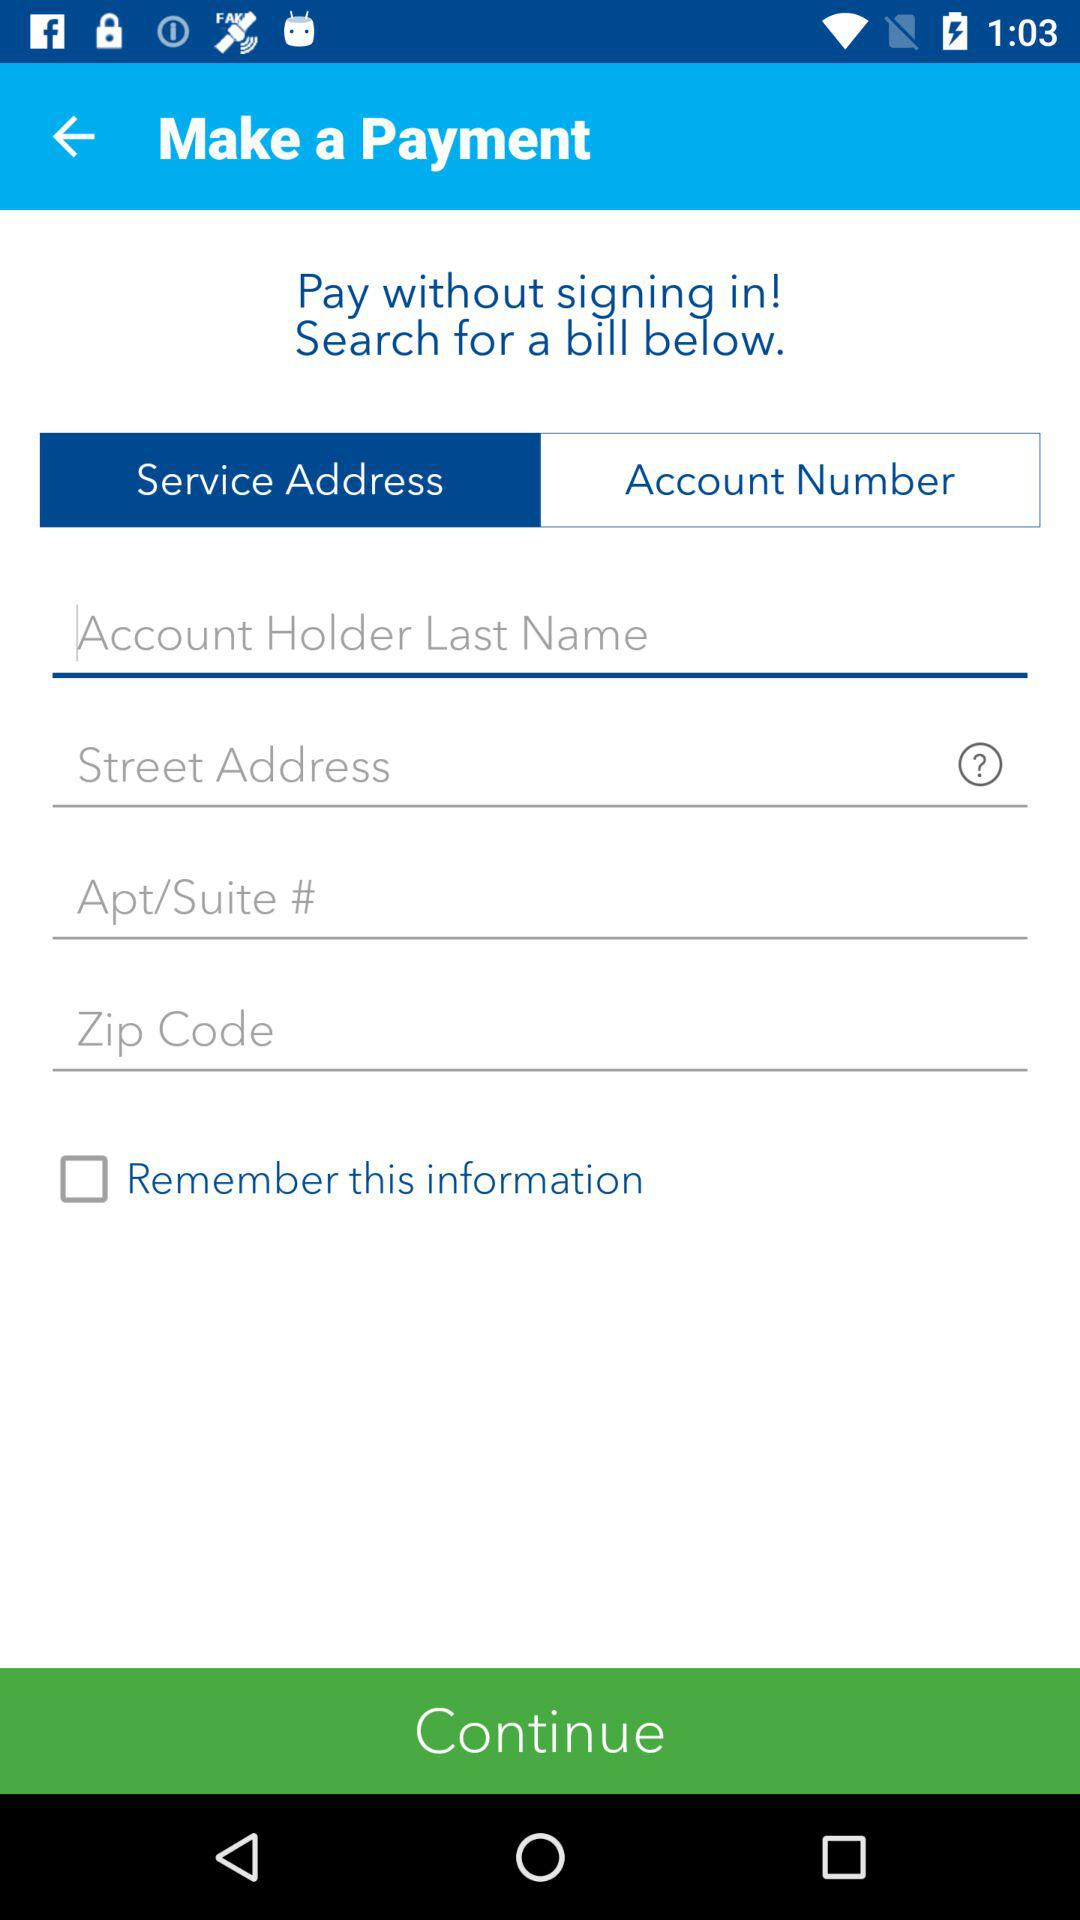What is the status of "Remember this information"? The status is "off". 